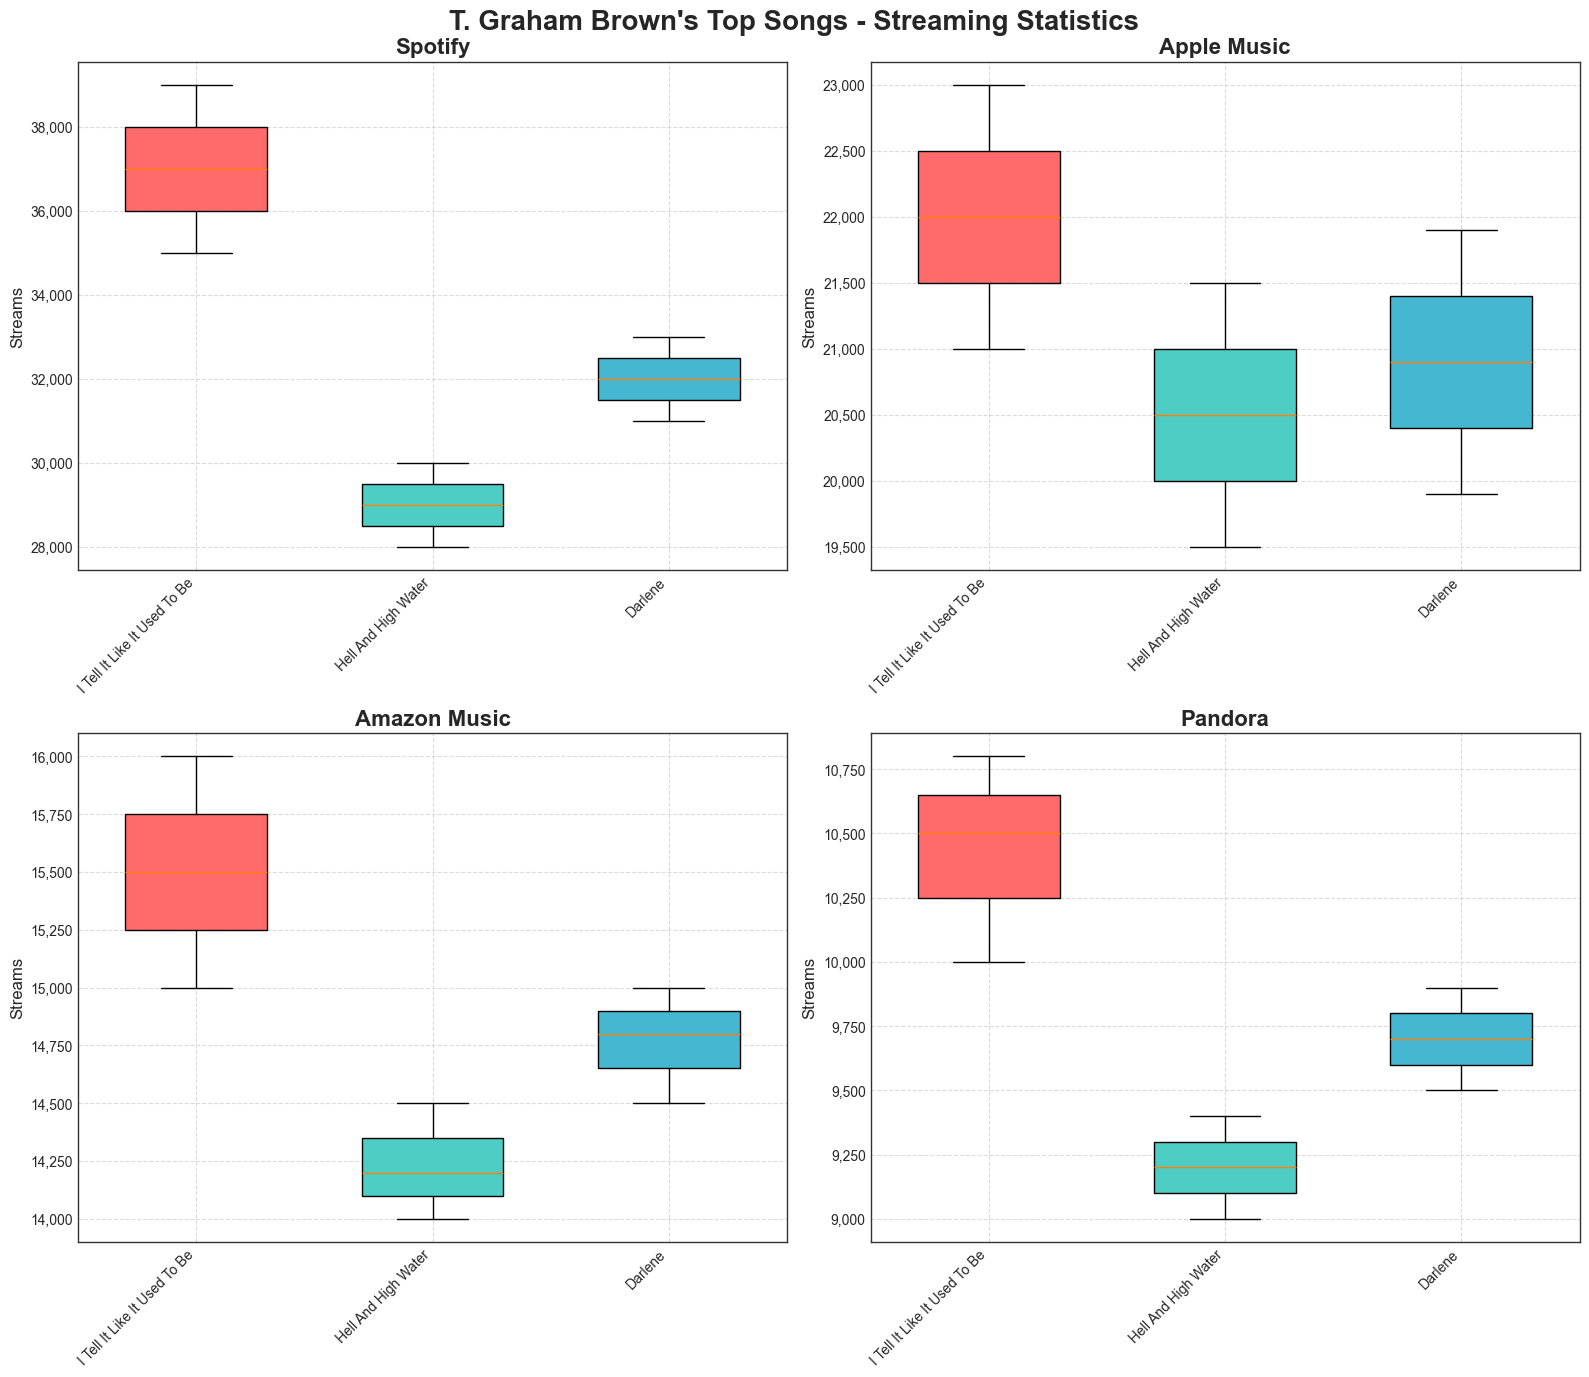What's the title of the figure? Look at the top of the figure where the title is usually located. The title is "T. Graham Brown's Top Songs - Streaming Statistics".
Answer: T. Graham Brown's Top Songs - Streaming Statistics Which platform has the highest median streams in March for the song "I Tell It Like It Used To Be"? Check the box plots for the song "I Tell It Like It Used To Be" under each platform in March and compare the median lines (the lines inside the boxes). Spotify has the highest median stream.
Answer: Spotify What is the range of the streams for "Hell And High Water" on Pandora in February? Look at the box plot for "Hell And High Water" on Pandora in February and check the minimum and maximum whiskers. The range is calculated as the maximum value minus the minimum value, i.e., 9200 (max) - 9200 (min).
Answer: 0 Which song showed the most consistent streaming numbers across all platforms in January? Consistency can be interpreted by the spread of the box plots in January for all platforms. "I Tell It Like It Used To Be" has less spread in the box plots (closer whiskers) compared to other songs across all platforms.
Answer: I Tell It Like It Used To Be How do the medians of "Darlene" streams on Amazon Music compare to those on Apple Music across the months? Check the central lines in the box plots of "Darlene" on Amazon Music and Apple Music across January, February, and March. Compare these median lines month by month. The medians on Apple Music are consistently higher than those on Amazon Music.
Answer: Apple Music has higher medians On which platform did "Hell And High Water" see the smallest increase in streams from January to March? Compare the changes in the medians from January to March for all platforms for the song "Hell And High Water". Pandora shows the smallest increase in streams.
Answer: Pandora Which platform had the largest variation in streams in February? Access the whisker lengths of all songs across platforms in February, which indicate the range (variation). Spotify shows the largest variations as it has the widest whiskers in February.
Answer: Spotify What is the average median stream count across all platforms for "Darlene" in March? Calculate the median stream counts in March for Apple Music (21900), Spotify (33000), Amazon Music (15000), and Pandora (9900), then find the average: (21900 + 33000 + 15000 + 9900) / 4 = 19950.
Answer: 19950 